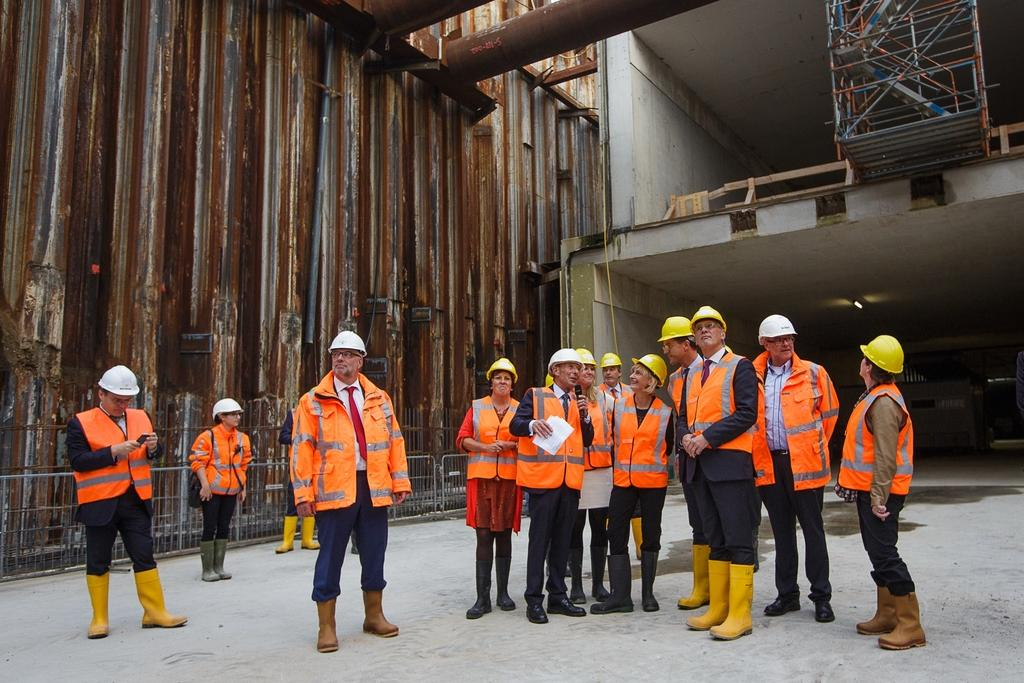What can be seen in the image? There are people standing in the image. Where are the people standing? The people are standing on a floor. What can be seen in the background of the image? There is an iron sheet, pipes, and frames in the background of the image. What type of feather can be seen on the people's pets in the image? There are no pets present in the image, and therefore no feathers can be observed. 